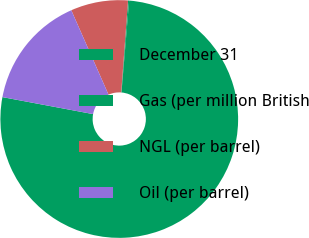Convert chart to OTSL. <chart><loc_0><loc_0><loc_500><loc_500><pie_chart><fcel>December 31<fcel>Gas (per million British<fcel>NGL (per barrel)<fcel>Oil (per barrel)<nl><fcel>76.62%<fcel>0.15%<fcel>7.79%<fcel>15.44%<nl></chart> 